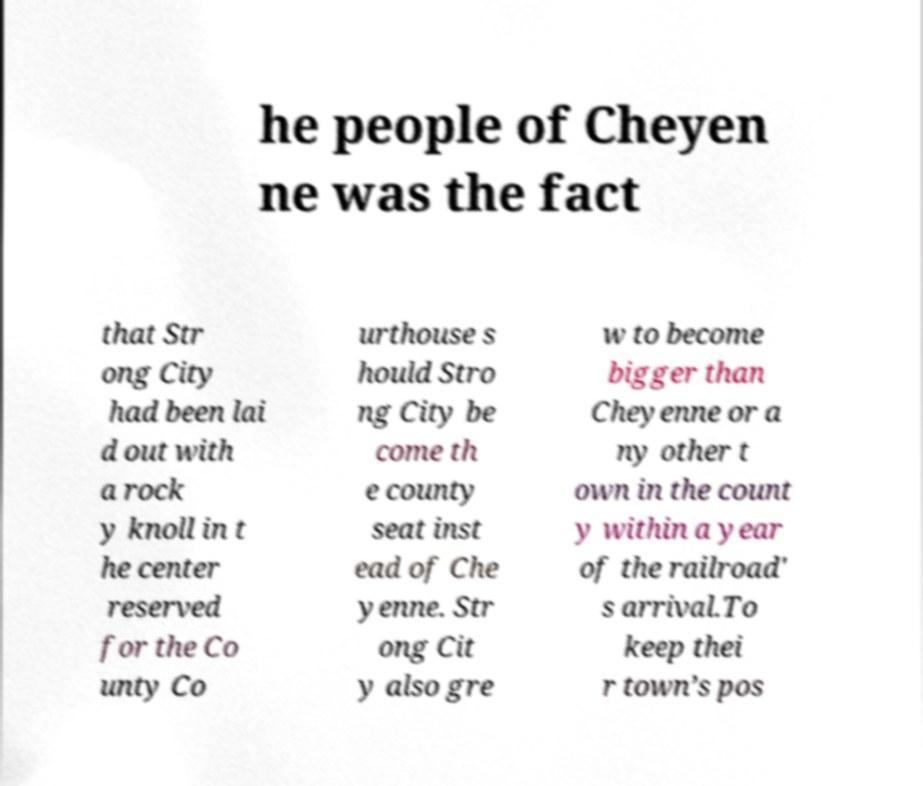There's text embedded in this image that I need extracted. Can you transcribe it verbatim? he people of Cheyen ne was the fact that Str ong City had been lai d out with a rock y knoll in t he center reserved for the Co unty Co urthouse s hould Stro ng City be come th e county seat inst ead of Che yenne. Str ong Cit y also gre w to become bigger than Cheyenne or a ny other t own in the count y within a year of the railroad' s arrival.To keep thei r town’s pos 